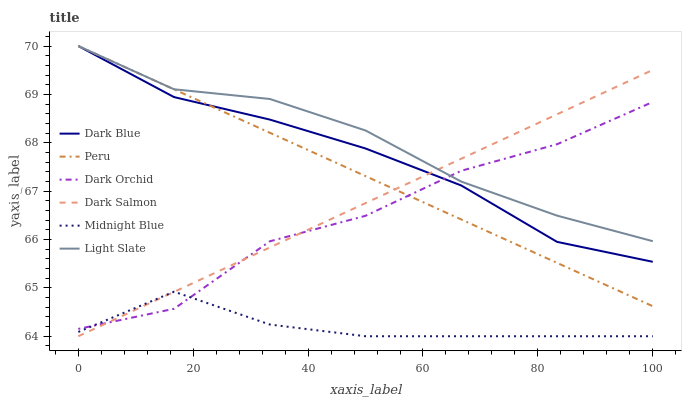Does Midnight Blue have the minimum area under the curve?
Answer yes or no. Yes. Does Light Slate have the maximum area under the curve?
Answer yes or no. Yes. Does Dark Salmon have the minimum area under the curve?
Answer yes or no. No. Does Dark Salmon have the maximum area under the curve?
Answer yes or no. No. Is Dark Salmon the smoothest?
Answer yes or no. Yes. Is Dark Orchid the roughest?
Answer yes or no. Yes. Is Light Slate the smoothest?
Answer yes or no. No. Is Light Slate the roughest?
Answer yes or no. No. Does Midnight Blue have the lowest value?
Answer yes or no. Yes. Does Light Slate have the lowest value?
Answer yes or no. No. Does Peru have the highest value?
Answer yes or no. Yes. Does Dark Salmon have the highest value?
Answer yes or no. No. Is Midnight Blue less than Dark Blue?
Answer yes or no. Yes. Is Dark Blue greater than Midnight Blue?
Answer yes or no. Yes. Does Dark Salmon intersect Dark Blue?
Answer yes or no. Yes. Is Dark Salmon less than Dark Blue?
Answer yes or no. No. Is Dark Salmon greater than Dark Blue?
Answer yes or no. No. Does Midnight Blue intersect Dark Blue?
Answer yes or no. No. 